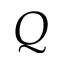<formula> <loc_0><loc_0><loc_500><loc_500>Q</formula> 